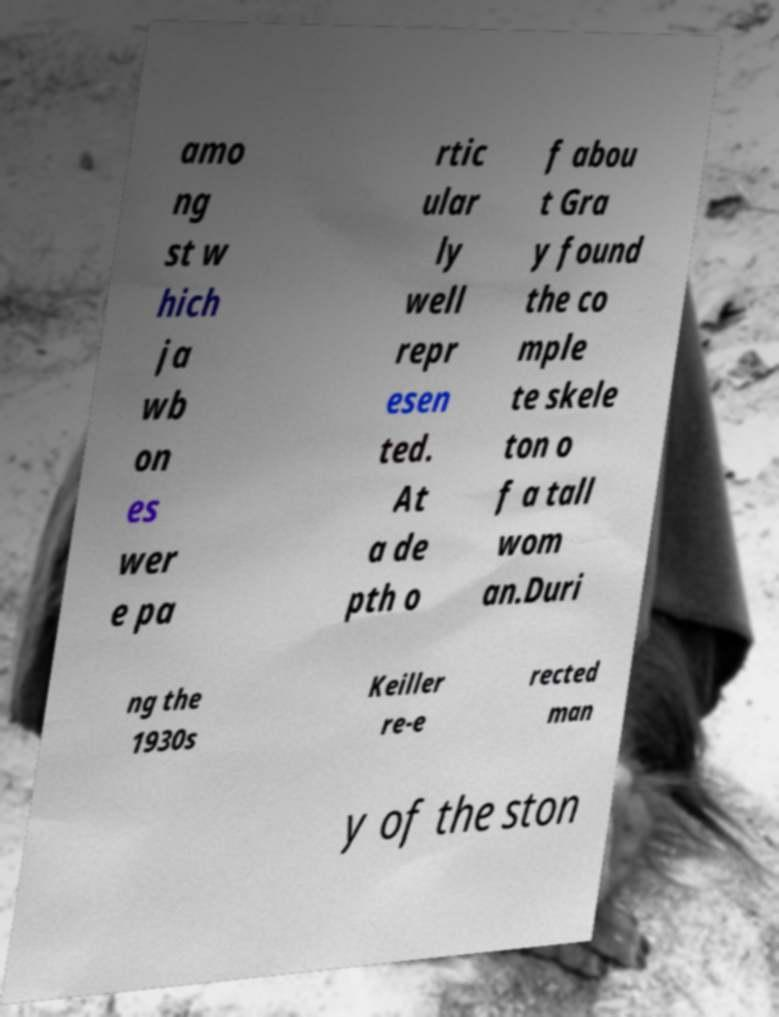There's text embedded in this image that I need extracted. Can you transcribe it verbatim? amo ng st w hich ja wb on es wer e pa rtic ular ly well repr esen ted. At a de pth o f abou t Gra y found the co mple te skele ton o f a tall wom an.Duri ng the 1930s Keiller re-e rected man y of the ston 